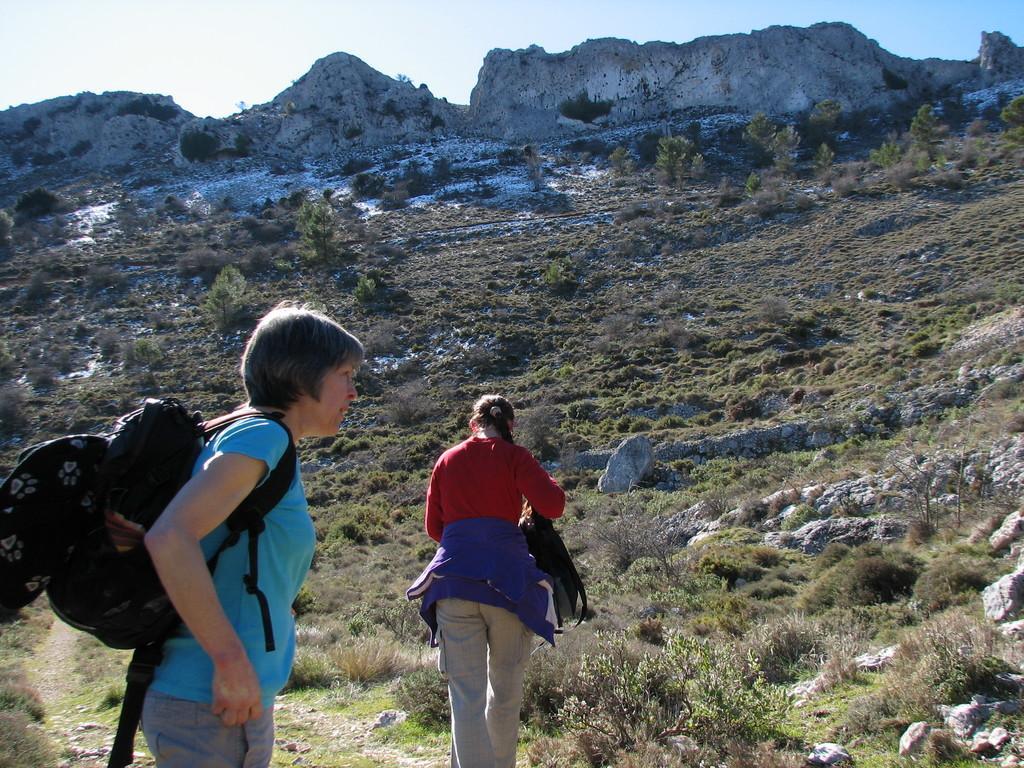Please provide a concise description of this image. In this picture we can see a woman wearing a bag on the left side. There is a person visible on the path. We can see some grass on the ground. There are a few stones and mountains are visible in the background. We can see the sky on top of the picture. 